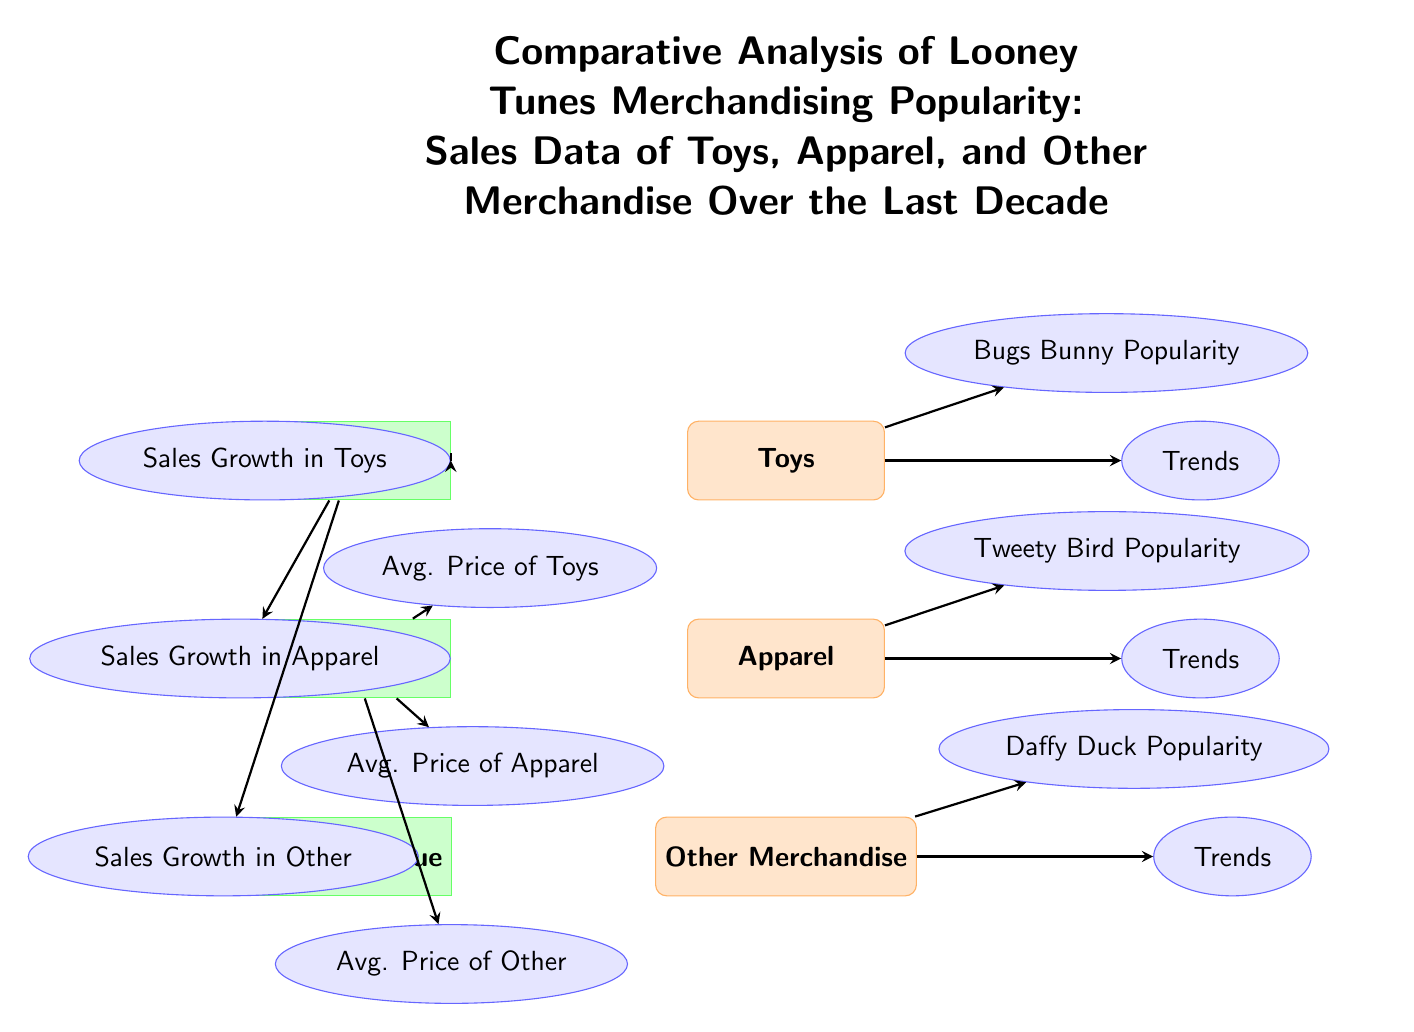What are the three main categories of merchandise? The diagram clearly lists three categories of merchandise: Toys, Apparel, and Other Merchandise. Each category is represented as a node, directly indicating the main focus areas of the merchandising analysis.
Answer: Toys, Apparel, Other Merchandise Which character's popularity is associated with apparel trends? The diagram shows an arrow from the Apparel category to the Tweety Bird Popularity node, indicating that Tweety Bird's popularity influences the trends in apparel merchandise.
Answer: Tweety Bird How many metrics are there related to sales growth? The diagram has one sales growth metric that branches out to three submetrics: Sales Growth in Toys, Sales Growth in Apparel, and Sales Growth in Other, indicating a total count of related metrics.
Answer: 3 What type of node connects 'Sales Revenue' to 'Toys'? Observing the diagram, 'Sales Revenue' is a metric node, and there is a directed arrow pointing to the node that represents sales growth in toys, indicating a connection type.
Answer: Metric Which category has trends associated with Bugs Bunny? The diagram shows an arrow from the Toys category directly leading to the Bugs Bunny Popularity node, indicating that trends in toys are specifically associated with this character.
Answer: Toys What relationship exists between average price and other merchandise? The average price metric has a direct connection to the average price of other merchandise, as indicated by the arrow in the diagram, signifying that average price influences this category.
Answer: Avg. Price of Other Which submetric is related to 'avg. price'? The diagram has three submetrics listed under average price: Avg. Price of Toys, Avg. Price of Apparel, and Avg. Price of Other. Each is directly linked through arrows to the average price metric, showing their relationship.
Answer: Avg. Price of Toys, Avg. Price of Apparel, Avg. Price of Other Why is the 'Sales Growth' metric important in the diagram? 'Sales Growth' serves as a primary metric that branches into separate growth metrics for toys, apparel, and other merchandise in the diagram, indicating its centrality to understanding overall sales performance across categories.
Answer: Central to understanding sales performance What is the visual distinction of categories vs metrics in the diagram? In the diagram, categories are represented by rectangular shapes with orange color fills, while metrics are denoted with green color-filled rectangles, making a clear visual distinction between the types of information presented.
Answer: Categories are orange; metrics are green 